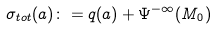Convert formula to latex. <formula><loc_0><loc_0><loc_500><loc_500>\sigma _ { t o t } ( a ) \colon = q ( a ) + \Psi ^ { - \infty } ( M _ { 0 } )</formula> 